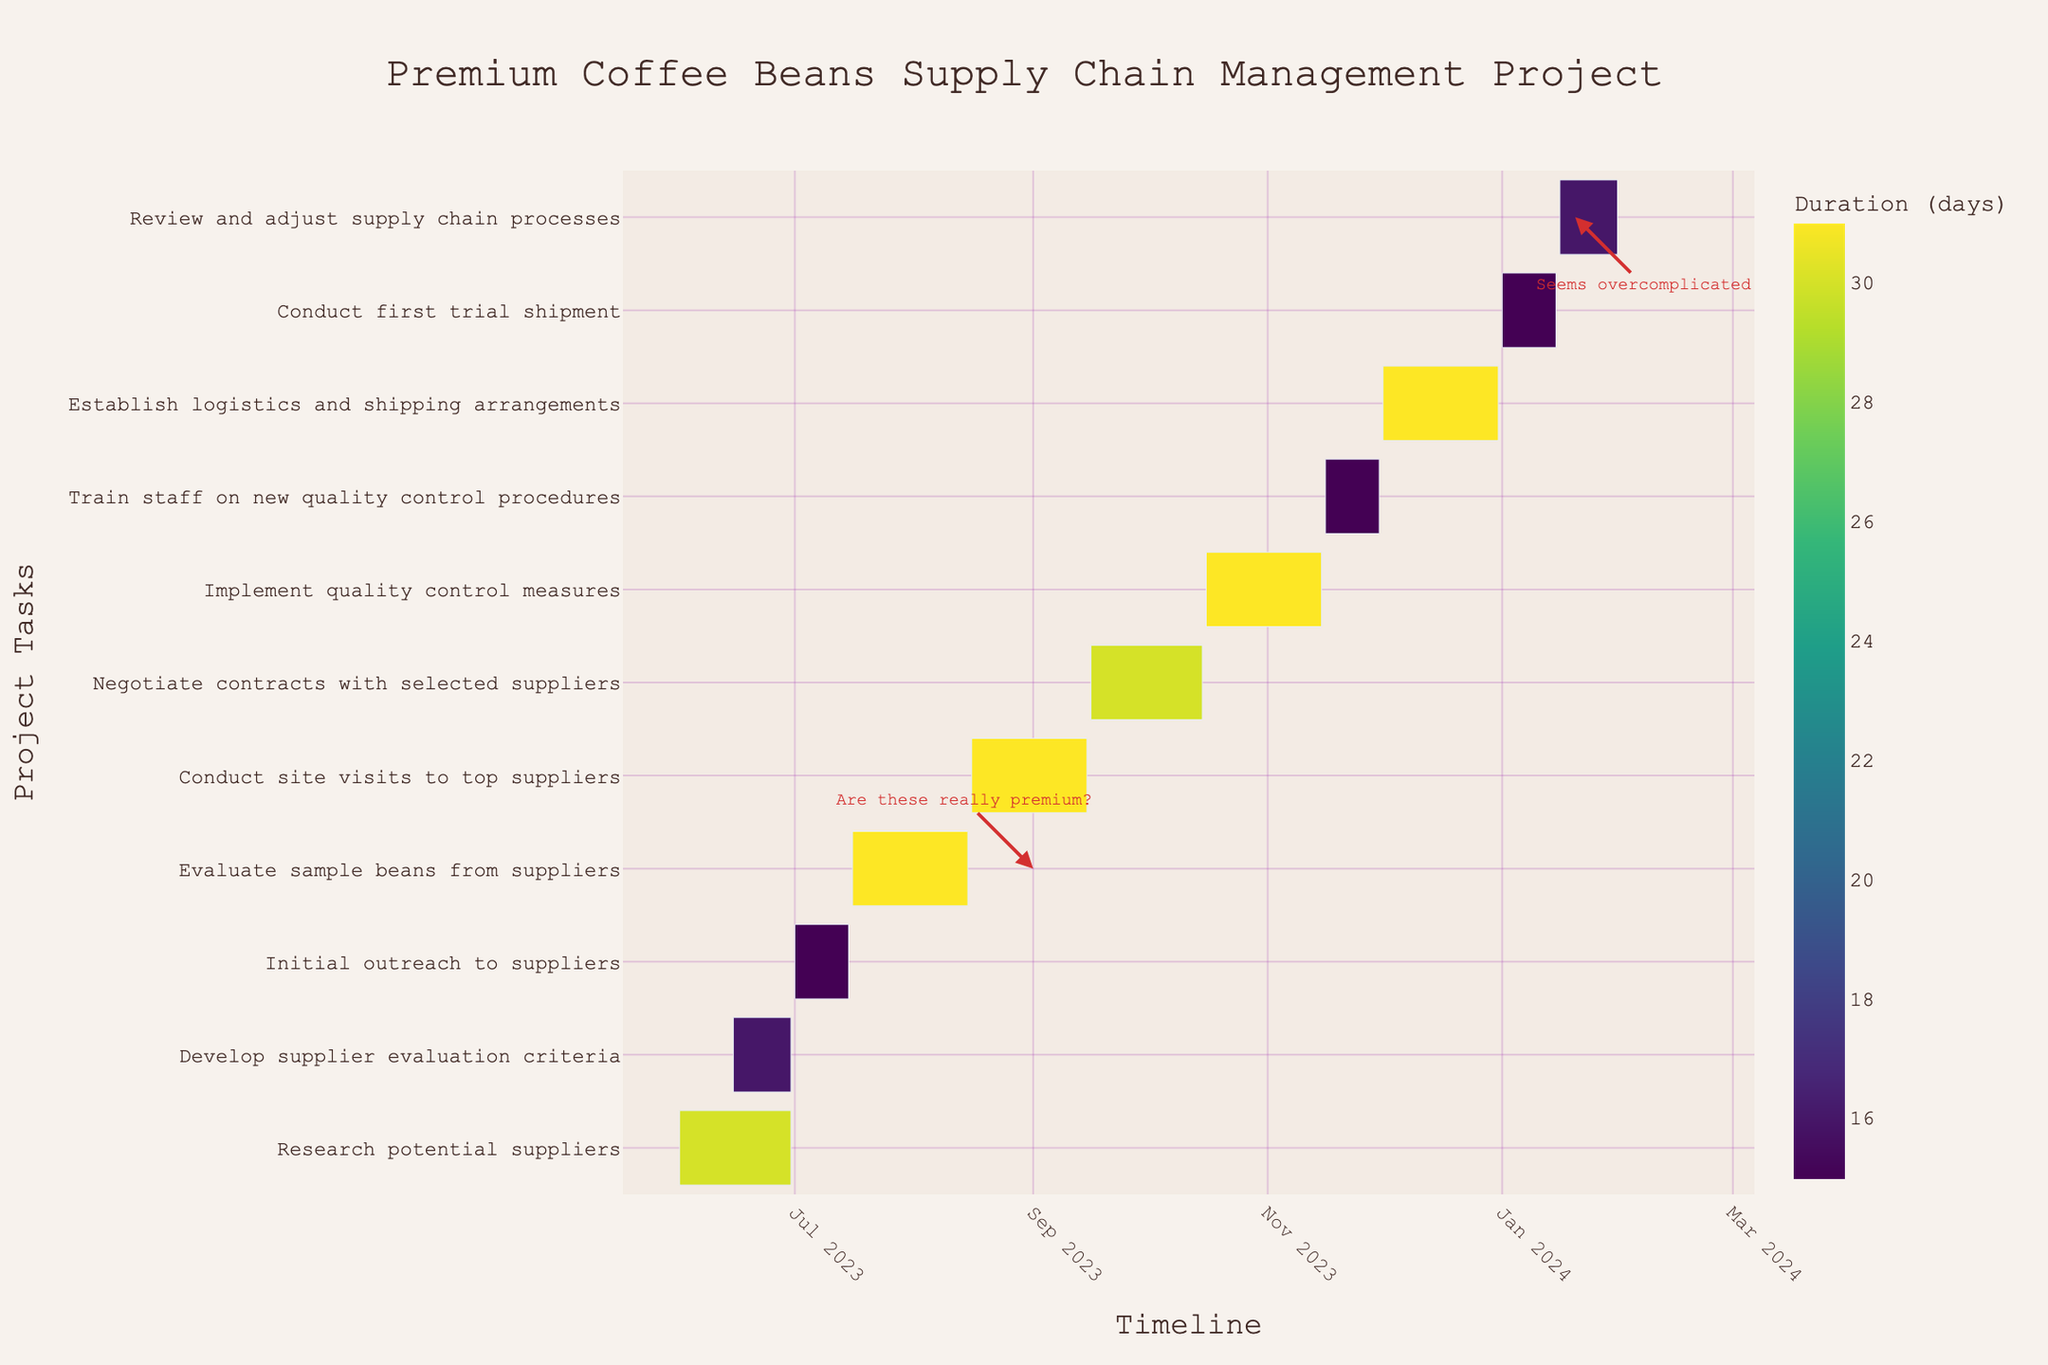What is the title of the Gantt chart? The title is found at the top center of the chart.
Answer: Premium Coffee Beans Supply Chain Management Project What is the duration of the task "Evaluate sample beans from suppliers"? Duration can be found by looking at the color axis or the hover information for the specific task.
Answer: 31 days Which task starts on August 16, 2023? You can find the start date along the timeline axis and match it to the task.
Answer: Conduct site visits to top suppliers What is the final task in the project timeline? The tasks are listed from top to bottom according to the timeline, so the bottom-most task is the final one.
Answer: Review and adjust supply chain processes Which task has the longest duration, and how many days is it? By comparing the lengths and colors of the bars, find the one that is the longest and check its duration.
Answer: Implement quality control measures, 31 days Which tasks overlap in their timeline? Identify tasks with bars that start and end over the same period. For example, look for tasks that coincide visually on the x-axis.
Answer: Research potential suppliers and Develop supplier evaluation criteria overlap from June 15 to June 30, 2023 What is the gap between "Negotiate contracts with selected suppliers" and "Implement quality control measures"? Calculating the gap involves checking the end date of the former task and the start date of the latter. "Negotiate contracts with selected suppliers" ends on October 15, and "Implement quality control measures" starts on October 16.
Answer: 0 days How many days are planned for staff training on new quality control procedures? Look at the bar labeled "Train staff on new quality control procedures" and check its associated duration.
Answer: 15 days Why might there be an annotation marked "Are these really premium?" near September 2023? This annotation appears during the "Evaluate sample beans from suppliers" task, possibly indicating skepticism about the quality of the sourced beans.
Answer: Doubts about bean quality When does the first trial shipment take place, and for how long? Check the timeline for the task named "Conduct first trial shipment" and note its start and end dates.
Answer: January 1 to January 15, 2024, 15 days 